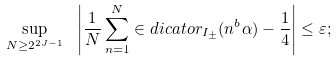Convert formula to latex. <formula><loc_0><loc_0><loc_500><loc_500>\sup _ { N \geq 2 ^ { 2 J - 1 } } \ \left | \frac { 1 } { N } \sum _ { n = 1 } ^ { N } \in d i c a t o r _ { I _ { \pm } } ( n ^ { b } \alpha ) - \frac { 1 } { 4 } \right | \leq \varepsilon ;</formula> 